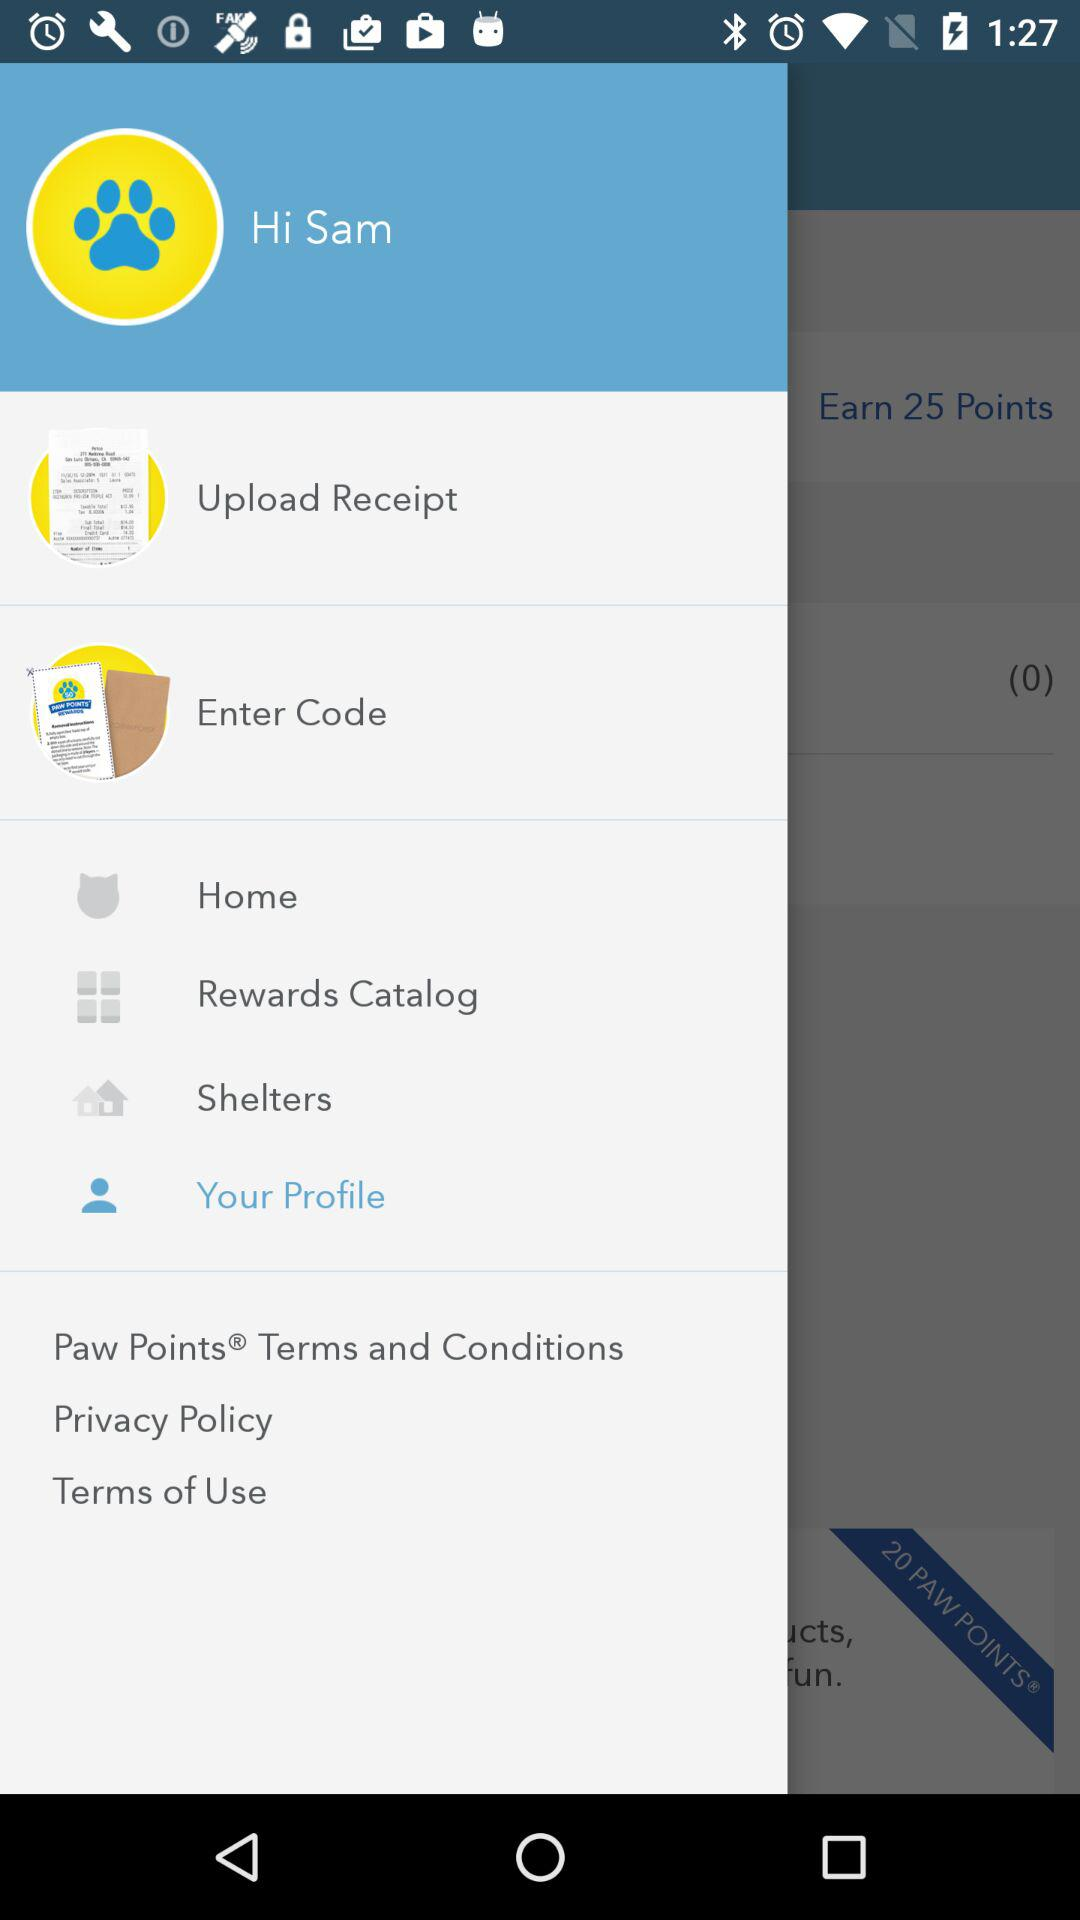What is the user name? The user name is Sam. 